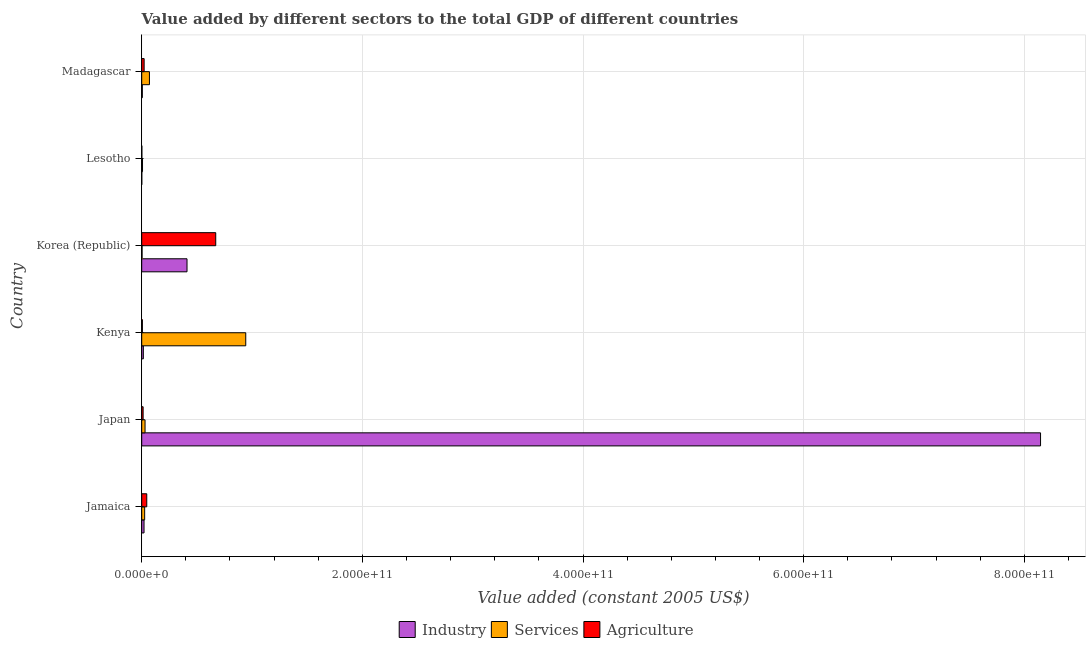How many groups of bars are there?
Give a very brief answer. 6. Are the number of bars on each tick of the Y-axis equal?
Give a very brief answer. Yes. What is the label of the 6th group of bars from the top?
Give a very brief answer. Jamaica. What is the value added by industrial sector in Kenya?
Your response must be concise. 1.46e+09. Across all countries, what is the maximum value added by services?
Your answer should be compact. 9.43e+1. Across all countries, what is the minimum value added by industrial sector?
Your answer should be very brief. 4.96e+07. In which country was the value added by services maximum?
Offer a terse response. Kenya. In which country was the value added by industrial sector minimum?
Give a very brief answer. Lesotho. What is the total value added by industrial sector in the graph?
Ensure brevity in your answer.  8.60e+11. What is the difference between the value added by services in Japan and that in Madagascar?
Give a very brief answer. -3.99e+09. What is the difference between the value added by industrial sector in Kenya and the value added by services in Jamaica?
Provide a short and direct response. -1.20e+09. What is the average value added by agricultural sector per country?
Your response must be concise. 1.26e+1. What is the difference between the value added by agricultural sector and value added by services in Korea (Republic)?
Keep it short and to the point. 6.68e+1. What is the ratio of the value added by industrial sector in Japan to that in Lesotho?
Your answer should be very brief. 1.64e+04. What is the difference between the highest and the second highest value added by industrial sector?
Ensure brevity in your answer.  7.74e+11. What is the difference between the highest and the lowest value added by agricultural sector?
Offer a terse response. 6.70e+1. Is the sum of the value added by agricultural sector in Kenya and Korea (Republic) greater than the maximum value added by services across all countries?
Give a very brief answer. No. What does the 1st bar from the top in Madagascar represents?
Keep it short and to the point. Agriculture. What does the 3rd bar from the bottom in Korea (Republic) represents?
Provide a short and direct response. Agriculture. How many bars are there?
Ensure brevity in your answer.  18. Are all the bars in the graph horizontal?
Provide a short and direct response. Yes. What is the difference between two consecutive major ticks on the X-axis?
Your answer should be compact. 2.00e+11. Where does the legend appear in the graph?
Give a very brief answer. Bottom center. How many legend labels are there?
Ensure brevity in your answer.  3. What is the title of the graph?
Keep it short and to the point. Value added by different sectors to the total GDP of different countries. What is the label or title of the X-axis?
Make the answer very short. Value added (constant 2005 US$). What is the Value added (constant 2005 US$) in Industry in Jamaica?
Keep it short and to the point. 2.10e+09. What is the Value added (constant 2005 US$) in Services in Jamaica?
Provide a short and direct response. 2.67e+09. What is the Value added (constant 2005 US$) of Agriculture in Jamaica?
Your answer should be very brief. 4.58e+09. What is the Value added (constant 2005 US$) in Industry in Japan?
Keep it short and to the point. 8.15e+11. What is the Value added (constant 2005 US$) in Services in Japan?
Your response must be concise. 3.01e+09. What is the Value added (constant 2005 US$) of Agriculture in Japan?
Make the answer very short. 1.27e+09. What is the Value added (constant 2005 US$) of Industry in Kenya?
Your answer should be compact. 1.46e+09. What is the Value added (constant 2005 US$) of Services in Kenya?
Your answer should be compact. 9.43e+1. What is the Value added (constant 2005 US$) of Agriculture in Kenya?
Your answer should be compact. 6.11e+08. What is the Value added (constant 2005 US$) of Industry in Korea (Republic)?
Your answer should be very brief. 4.11e+1. What is the Value added (constant 2005 US$) of Services in Korea (Republic)?
Offer a very short reply. 3.05e+08. What is the Value added (constant 2005 US$) in Agriculture in Korea (Republic)?
Your answer should be compact. 6.71e+1. What is the Value added (constant 2005 US$) of Industry in Lesotho?
Make the answer very short. 4.96e+07. What is the Value added (constant 2005 US$) in Services in Lesotho?
Provide a short and direct response. 7.20e+08. What is the Value added (constant 2005 US$) in Agriculture in Lesotho?
Provide a short and direct response. 1.21e+08. What is the Value added (constant 2005 US$) in Industry in Madagascar?
Offer a very short reply. 5.53e+08. What is the Value added (constant 2005 US$) in Services in Madagascar?
Provide a succinct answer. 7.00e+09. What is the Value added (constant 2005 US$) of Agriculture in Madagascar?
Your answer should be compact. 2.19e+09. Across all countries, what is the maximum Value added (constant 2005 US$) of Industry?
Offer a terse response. 8.15e+11. Across all countries, what is the maximum Value added (constant 2005 US$) of Services?
Give a very brief answer. 9.43e+1. Across all countries, what is the maximum Value added (constant 2005 US$) in Agriculture?
Your answer should be very brief. 6.71e+1. Across all countries, what is the minimum Value added (constant 2005 US$) of Industry?
Keep it short and to the point. 4.96e+07. Across all countries, what is the minimum Value added (constant 2005 US$) in Services?
Offer a terse response. 3.05e+08. Across all countries, what is the minimum Value added (constant 2005 US$) of Agriculture?
Your answer should be very brief. 1.21e+08. What is the total Value added (constant 2005 US$) in Industry in the graph?
Provide a succinct answer. 8.60e+11. What is the total Value added (constant 2005 US$) of Services in the graph?
Your response must be concise. 1.08e+11. What is the total Value added (constant 2005 US$) of Agriculture in the graph?
Make the answer very short. 7.59e+1. What is the difference between the Value added (constant 2005 US$) in Industry in Jamaica and that in Japan?
Give a very brief answer. -8.13e+11. What is the difference between the Value added (constant 2005 US$) in Services in Jamaica and that in Japan?
Make the answer very short. -3.45e+08. What is the difference between the Value added (constant 2005 US$) in Agriculture in Jamaica and that in Japan?
Provide a short and direct response. 3.31e+09. What is the difference between the Value added (constant 2005 US$) of Industry in Jamaica and that in Kenya?
Provide a succinct answer. 6.32e+08. What is the difference between the Value added (constant 2005 US$) in Services in Jamaica and that in Kenya?
Offer a terse response. -9.16e+1. What is the difference between the Value added (constant 2005 US$) of Agriculture in Jamaica and that in Kenya?
Give a very brief answer. 3.97e+09. What is the difference between the Value added (constant 2005 US$) of Industry in Jamaica and that in Korea (Republic)?
Offer a very short reply. -3.90e+1. What is the difference between the Value added (constant 2005 US$) in Services in Jamaica and that in Korea (Republic)?
Your response must be concise. 2.36e+09. What is the difference between the Value added (constant 2005 US$) of Agriculture in Jamaica and that in Korea (Republic)?
Give a very brief answer. -6.25e+1. What is the difference between the Value added (constant 2005 US$) of Industry in Jamaica and that in Lesotho?
Ensure brevity in your answer.  2.05e+09. What is the difference between the Value added (constant 2005 US$) of Services in Jamaica and that in Lesotho?
Provide a short and direct response. 1.95e+09. What is the difference between the Value added (constant 2005 US$) in Agriculture in Jamaica and that in Lesotho?
Your answer should be very brief. 4.46e+09. What is the difference between the Value added (constant 2005 US$) of Industry in Jamaica and that in Madagascar?
Your answer should be very brief. 1.54e+09. What is the difference between the Value added (constant 2005 US$) of Services in Jamaica and that in Madagascar?
Your response must be concise. -4.33e+09. What is the difference between the Value added (constant 2005 US$) in Agriculture in Jamaica and that in Madagascar?
Keep it short and to the point. 2.39e+09. What is the difference between the Value added (constant 2005 US$) in Industry in Japan and that in Kenya?
Provide a short and direct response. 8.13e+11. What is the difference between the Value added (constant 2005 US$) in Services in Japan and that in Kenya?
Keep it short and to the point. -9.13e+1. What is the difference between the Value added (constant 2005 US$) of Agriculture in Japan and that in Kenya?
Make the answer very short. 6.59e+08. What is the difference between the Value added (constant 2005 US$) in Industry in Japan and that in Korea (Republic)?
Your answer should be very brief. 7.74e+11. What is the difference between the Value added (constant 2005 US$) in Services in Japan and that in Korea (Republic)?
Provide a succinct answer. 2.71e+09. What is the difference between the Value added (constant 2005 US$) of Agriculture in Japan and that in Korea (Republic)?
Make the answer very short. -6.58e+1. What is the difference between the Value added (constant 2005 US$) in Industry in Japan and that in Lesotho?
Keep it short and to the point. 8.15e+11. What is the difference between the Value added (constant 2005 US$) in Services in Japan and that in Lesotho?
Your answer should be very brief. 2.29e+09. What is the difference between the Value added (constant 2005 US$) of Agriculture in Japan and that in Lesotho?
Provide a short and direct response. 1.15e+09. What is the difference between the Value added (constant 2005 US$) in Industry in Japan and that in Madagascar?
Keep it short and to the point. 8.14e+11. What is the difference between the Value added (constant 2005 US$) in Services in Japan and that in Madagascar?
Keep it short and to the point. -3.99e+09. What is the difference between the Value added (constant 2005 US$) in Agriculture in Japan and that in Madagascar?
Provide a short and direct response. -9.18e+08. What is the difference between the Value added (constant 2005 US$) in Industry in Kenya and that in Korea (Republic)?
Give a very brief answer. -3.96e+1. What is the difference between the Value added (constant 2005 US$) in Services in Kenya and that in Korea (Republic)?
Your response must be concise. 9.40e+1. What is the difference between the Value added (constant 2005 US$) in Agriculture in Kenya and that in Korea (Republic)?
Offer a terse response. -6.65e+1. What is the difference between the Value added (constant 2005 US$) in Industry in Kenya and that in Lesotho?
Provide a succinct answer. 1.41e+09. What is the difference between the Value added (constant 2005 US$) in Services in Kenya and that in Lesotho?
Offer a terse response. 9.36e+1. What is the difference between the Value added (constant 2005 US$) in Agriculture in Kenya and that in Lesotho?
Offer a very short reply. 4.90e+08. What is the difference between the Value added (constant 2005 US$) in Industry in Kenya and that in Madagascar?
Make the answer very short. 9.12e+08. What is the difference between the Value added (constant 2005 US$) of Services in Kenya and that in Madagascar?
Your response must be concise. 8.73e+1. What is the difference between the Value added (constant 2005 US$) in Agriculture in Kenya and that in Madagascar?
Keep it short and to the point. -1.58e+09. What is the difference between the Value added (constant 2005 US$) of Industry in Korea (Republic) and that in Lesotho?
Give a very brief answer. 4.10e+1. What is the difference between the Value added (constant 2005 US$) in Services in Korea (Republic) and that in Lesotho?
Your answer should be compact. -4.15e+08. What is the difference between the Value added (constant 2005 US$) in Agriculture in Korea (Republic) and that in Lesotho?
Your answer should be compact. 6.70e+1. What is the difference between the Value added (constant 2005 US$) of Industry in Korea (Republic) and that in Madagascar?
Provide a short and direct response. 4.05e+1. What is the difference between the Value added (constant 2005 US$) in Services in Korea (Republic) and that in Madagascar?
Make the answer very short. -6.69e+09. What is the difference between the Value added (constant 2005 US$) in Agriculture in Korea (Republic) and that in Madagascar?
Offer a very short reply. 6.49e+1. What is the difference between the Value added (constant 2005 US$) in Industry in Lesotho and that in Madagascar?
Give a very brief answer. -5.03e+08. What is the difference between the Value added (constant 2005 US$) of Services in Lesotho and that in Madagascar?
Provide a succinct answer. -6.28e+09. What is the difference between the Value added (constant 2005 US$) of Agriculture in Lesotho and that in Madagascar?
Your answer should be compact. -2.07e+09. What is the difference between the Value added (constant 2005 US$) in Industry in Jamaica and the Value added (constant 2005 US$) in Services in Japan?
Your answer should be very brief. -9.15e+08. What is the difference between the Value added (constant 2005 US$) in Industry in Jamaica and the Value added (constant 2005 US$) in Agriculture in Japan?
Make the answer very short. 8.26e+08. What is the difference between the Value added (constant 2005 US$) in Services in Jamaica and the Value added (constant 2005 US$) in Agriculture in Japan?
Provide a short and direct response. 1.40e+09. What is the difference between the Value added (constant 2005 US$) in Industry in Jamaica and the Value added (constant 2005 US$) in Services in Kenya?
Your answer should be very brief. -9.22e+1. What is the difference between the Value added (constant 2005 US$) of Industry in Jamaica and the Value added (constant 2005 US$) of Agriculture in Kenya?
Provide a succinct answer. 1.49e+09. What is the difference between the Value added (constant 2005 US$) of Services in Jamaica and the Value added (constant 2005 US$) of Agriculture in Kenya?
Make the answer very short. 2.06e+09. What is the difference between the Value added (constant 2005 US$) in Industry in Jamaica and the Value added (constant 2005 US$) in Services in Korea (Republic)?
Your response must be concise. 1.79e+09. What is the difference between the Value added (constant 2005 US$) of Industry in Jamaica and the Value added (constant 2005 US$) of Agriculture in Korea (Republic)?
Keep it short and to the point. -6.50e+1. What is the difference between the Value added (constant 2005 US$) in Services in Jamaica and the Value added (constant 2005 US$) in Agriculture in Korea (Republic)?
Ensure brevity in your answer.  -6.44e+1. What is the difference between the Value added (constant 2005 US$) of Industry in Jamaica and the Value added (constant 2005 US$) of Services in Lesotho?
Your answer should be very brief. 1.38e+09. What is the difference between the Value added (constant 2005 US$) of Industry in Jamaica and the Value added (constant 2005 US$) of Agriculture in Lesotho?
Give a very brief answer. 1.98e+09. What is the difference between the Value added (constant 2005 US$) in Services in Jamaica and the Value added (constant 2005 US$) in Agriculture in Lesotho?
Keep it short and to the point. 2.55e+09. What is the difference between the Value added (constant 2005 US$) of Industry in Jamaica and the Value added (constant 2005 US$) of Services in Madagascar?
Your answer should be compact. -4.90e+09. What is the difference between the Value added (constant 2005 US$) of Industry in Jamaica and the Value added (constant 2005 US$) of Agriculture in Madagascar?
Ensure brevity in your answer.  -9.23e+07. What is the difference between the Value added (constant 2005 US$) of Services in Jamaica and the Value added (constant 2005 US$) of Agriculture in Madagascar?
Give a very brief answer. 4.78e+08. What is the difference between the Value added (constant 2005 US$) in Industry in Japan and the Value added (constant 2005 US$) in Services in Kenya?
Give a very brief answer. 7.20e+11. What is the difference between the Value added (constant 2005 US$) of Industry in Japan and the Value added (constant 2005 US$) of Agriculture in Kenya?
Your answer should be very brief. 8.14e+11. What is the difference between the Value added (constant 2005 US$) of Services in Japan and the Value added (constant 2005 US$) of Agriculture in Kenya?
Offer a very short reply. 2.40e+09. What is the difference between the Value added (constant 2005 US$) in Industry in Japan and the Value added (constant 2005 US$) in Services in Korea (Republic)?
Keep it short and to the point. 8.14e+11. What is the difference between the Value added (constant 2005 US$) of Industry in Japan and the Value added (constant 2005 US$) of Agriculture in Korea (Republic)?
Your answer should be compact. 7.48e+11. What is the difference between the Value added (constant 2005 US$) of Services in Japan and the Value added (constant 2005 US$) of Agriculture in Korea (Republic)?
Provide a succinct answer. -6.41e+1. What is the difference between the Value added (constant 2005 US$) of Industry in Japan and the Value added (constant 2005 US$) of Services in Lesotho?
Ensure brevity in your answer.  8.14e+11. What is the difference between the Value added (constant 2005 US$) in Industry in Japan and the Value added (constant 2005 US$) in Agriculture in Lesotho?
Your answer should be very brief. 8.15e+11. What is the difference between the Value added (constant 2005 US$) in Services in Japan and the Value added (constant 2005 US$) in Agriculture in Lesotho?
Your answer should be compact. 2.89e+09. What is the difference between the Value added (constant 2005 US$) in Industry in Japan and the Value added (constant 2005 US$) in Services in Madagascar?
Your response must be concise. 8.08e+11. What is the difference between the Value added (constant 2005 US$) in Industry in Japan and the Value added (constant 2005 US$) in Agriculture in Madagascar?
Ensure brevity in your answer.  8.13e+11. What is the difference between the Value added (constant 2005 US$) in Services in Japan and the Value added (constant 2005 US$) in Agriculture in Madagascar?
Offer a terse response. 8.22e+08. What is the difference between the Value added (constant 2005 US$) of Industry in Kenya and the Value added (constant 2005 US$) of Services in Korea (Republic)?
Provide a short and direct response. 1.16e+09. What is the difference between the Value added (constant 2005 US$) of Industry in Kenya and the Value added (constant 2005 US$) of Agriculture in Korea (Republic)?
Your response must be concise. -6.56e+1. What is the difference between the Value added (constant 2005 US$) in Services in Kenya and the Value added (constant 2005 US$) in Agriculture in Korea (Republic)?
Keep it short and to the point. 2.72e+1. What is the difference between the Value added (constant 2005 US$) in Industry in Kenya and the Value added (constant 2005 US$) in Services in Lesotho?
Ensure brevity in your answer.  7.44e+08. What is the difference between the Value added (constant 2005 US$) in Industry in Kenya and the Value added (constant 2005 US$) in Agriculture in Lesotho?
Ensure brevity in your answer.  1.34e+09. What is the difference between the Value added (constant 2005 US$) of Services in Kenya and the Value added (constant 2005 US$) of Agriculture in Lesotho?
Your answer should be compact. 9.42e+1. What is the difference between the Value added (constant 2005 US$) of Industry in Kenya and the Value added (constant 2005 US$) of Services in Madagascar?
Ensure brevity in your answer.  -5.53e+09. What is the difference between the Value added (constant 2005 US$) in Industry in Kenya and the Value added (constant 2005 US$) in Agriculture in Madagascar?
Ensure brevity in your answer.  -7.24e+08. What is the difference between the Value added (constant 2005 US$) of Services in Kenya and the Value added (constant 2005 US$) of Agriculture in Madagascar?
Give a very brief answer. 9.21e+1. What is the difference between the Value added (constant 2005 US$) of Industry in Korea (Republic) and the Value added (constant 2005 US$) of Services in Lesotho?
Keep it short and to the point. 4.03e+1. What is the difference between the Value added (constant 2005 US$) of Industry in Korea (Republic) and the Value added (constant 2005 US$) of Agriculture in Lesotho?
Your answer should be compact. 4.09e+1. What is the difference between the Value added (constant 2005 US$) in Services in Korea (Republic) and the Value added (constant 2005 US$) in Agriculture in Lesotho?
Your answer should be compact. 1.84e+08. What is the difference between the Value added (constant 2005 US$) in Industry in Korea (Republic) and the Value added (constant 2005 US$) in Services in Madagascar?
Provide a short and direct response. 3.41e+1. What is the difference between the Value added (constant 2005 US$) in Industry in Korea (Republic) and the Value added (constant 2005 US$) in Agriculture in Madagascar?
Give a very brief answer. 3.89e+1. What is the difference between the Value added (constant 2005 US$) of Services in Korea (Republic) and the Value added (constant 2005 US$) of Agriculture in Madagascar?
Offer a very short reply. -1.88e+09. What is the difference between the Value added (constant 2005 US$) of Industry in Lesotho and the Value added (constant 2005 US$) of Services in Madagascar?
Provide a succinct answer. -6.95e+09. What is the difference between the Value added (constant 2005 US$) in Industry in Lesotho and the Value added (constant 2005 US$) in Agriculture in Madagascar?
Your response must be concise. -2.14e+09. What is the difference between the Value added (constant 2005 US$) of Services in Lesotho and the Value added (constant 2005 US$) of Agriculture in Madagascar?
Provide a succinct answer. -1.47e+09. What is the average Value added (constant 2005 US$) in Industry per country?
Your answer should be compact. 1.43e+11. What is the average Value added (constant 2005 US$) of Services per country?
Provide a short and direct response. 1.80e+1. What is the average Value added (constant 2005 US$) in Agriculture per country?
Give a very brief answer. 1.26e+1. What is the difference between the Value added (constant 2005 US$) of Industry and Value added (constant 2005 US$) of Services in Jamaica?
Keep it short and to the point. -5.70e+08. What is the difference between the Value added (constant 2005 US$) of Industry and Value added (constant 2005 US$) of Agriculture in Jamaica?
Offer a very short reply. -2.48e+09. What is the difference between the Value added (constant 2005 US$) of Services and Value added (constant 2005 US$) of Agriculture in Jamaica?
Give a very brief answer. -1.91e+09. What is the difference between the Value added (constant 2005 US$) of Industry and Value added (constant 2005 US$) of Services in Japan?
Provide a succinct answer. 8.12e+11. What is the difference between the Value added (constant 2005 US$) in Industry and Value added (constant 2005 US$) in Agriculture in Japan?
Provide a succinct answer. 8.13e+11. What is the difference between the Value added (constant 2005 US$) of Services and Value added (constant 2005 US$) of Agriculture in Japan?
Offer a very short reply. 1.74e+09. What is the difference between the Value added (constant 2005 US$) in Industry and Value added (constant 2005 US$) in Services in Kenya?
Provide a succinct answer. -9.28e+1. What is the difference between the Value added (constant 2005 US$) in Industry and Value added (constant 2005 US$) in Agriculture in Kenya?
Offer a terse response. 8.53e+08. What is the difference between the Value added (constant 2005 US$) of Services and Value added (constant 2005 US$) of Agriculture in Kenya?
Provide a short and direct response. 9.37e+1. What is the difference between the Value added (constant 2005 US$) of Industry and Value added (constant 2005 US$) of Services in Korea (Republic)?
Ensure brevity in your answer.  4.08e+1. What is the difference between the Value added (constant 2005 US$) of Industry and Value added (constant 2005 US$) of Agriculture in Korea (Republic)?
Your response must be concise. -2.60e+1. What is the difference between the Value added (constant 2005 US$) in Services and Value added (constant 2005 US$) in Agriculture in Korea (Republic)?
Provide a short and direct response. -6.68e+1. What is the difference between the Value added (constant 2005 US$) in Industry and Value added (constant 2005 US$) in Services in Lesotho?
Your answer should be very brief. -6.70e+08. What is the difference between the Value added (constant 2005 US$) in Industry and Value added (constant 2005 US$) in Agriculture in Lesotho?
Offer a terse response. -7.12e+07. What is the difference between the Value added (constant 2005 US$) in Services and Value added (constant 2005 US$) in Agriculture in Lesotho?
Provide a succinct answer. 5.99e+08. What is the difference between the Value added (constant 2005 US$) in Industry and Value added (constant 2005 US$) in Services in Madagascar?
Make the answer very short. -6.44e+09. What is the difference between the Value added (constant 2005 US$) in Industry and Value added (constant 2005 US$) in Agriculture in Madagascar?
Offer a very short reply. -1.64e+09. What is the difference between the Value added (constant 2005 US$) of Services and Value added (constant 2005 US$) of Agriculture in Madagascar?
Keep it short and to the point. 4.81e+09. What is the ratio of the Value added (constant 2005 US$) of Industry in Jamaica to that in Japan?
Ensure brevity in your answer.  0. What is the ratio of the Value added (constant 2005 US$) in Services in Jamaica to that in Japan?
Make the answer very short. 0.89. What is the ratio of the Value added (constant 2005 US$) in Agriculture in Jamaica to that in Japan?
Give a very brief answer. 3.6. What is the ratio of the Value added (constant 2005 US$) of Industry in Jamaica to that in Kenya?
Your response must be concise. 1.43. What is the ratio of the Value added (constant 2005 US$) in Services in Jamaica to that in Kenya?
Your answer should be compact. 0.03. What is the ratio of the Value added (constant 2005 US$) of Agriculture in Jamaica to that in Kenya?
Ensure brevity in your answer.  7.49. What is the ratio of the Value added (constant 2005 US$) in Industry in Jamaica to that in Korea (Republic)?
Keep it short and to the point. 0.05. What is the ratio of the Value added (constant 2005 US$) of Services in Jamaica to that in Korea (Republic)?
Provide a succinct answer. 8.75. What is the ratio of the Value added (constant 2005 US$) in Agriculture in Jamaica to that in Korea (Republic)?
Give a very brief answer. 0.07. What is the ratio of the Value added (constant 2005 US$) of Industry in Jamaica to that in Lesotho?
Your response must be concise. 42.25. What is the ratio of the Value added (constant 2005 US$) of Services in Jamaica to that in Lesotho?
Provide a short and direct response. 3.7. What is the ratio of the Value added (constant 2005 US$) of Agriculture in Jamaica to that in Lesotho?
Your answer should be very brief. 37.89. What is the ratio of the Value added (constant 2005 US$) in Industry in Jamaica to that in Madagascar?
Your response must be concise. 3.79. What is the ratio of the Value added (constant 2005 US$) in Services in Jamaica to that in Madagascar?
Your answer should be compact. 0.38. What is the ratio of the Value added (constant 2005 US$) in Agriculture in Jamaica to that in Madagascar?
Keep it short and to the point. 2.09. What is the ratio of the Value added (constant 2005 US$) in Industry in Japan to that in Kenya?
Your response must be concise. 556.49. What is the ratio of the Value added (constant 2005 US$) in Services in Japan to that in Kenya?
Ensure brevity in your answer.  0.03. What is the ratio of the Value added (constant 2005 US$) of Agriculture in Japan to that in Kenya?
Your answer should be compact. 2.08. What is the ratio of the Value added (constant 2005 US$) of Industry in Japan to that in Korea (Republic)?
Offer a very short reply. 19.84. What is the ratio of the Value added (constant 2005 US$) in Services in Japan to that in Korea (Republic)?
Give a very brief answer. 9.88. What is the ratio of the Value added (constant 2005 US$) in Agriculture in Japan to that in Korea (Republic)?
Ensure brevity in your answer.  0.02. What is the ratio of the Value added (constant 2005 US$) in Industry in Japan to that in Lesotho?
Your answer should be very brief. 1.64e+04. What is the ratio of the Value added (constant 2005 US$) in Services in Japan to that in Lesotho?
Offer a very short reply. 4.18. What is the ratio of the Value added (constant 2005 US$) in Agriculture in Japan to that in Lesotho?
Your response must be concise. 10.51. What is the ratio of the Value added (constant 2005 US$) of Industry in Japan to that in Madagascar?
Keep it short and to the point. 1474.61. What is the ratio of the Value added (constant 2005 US$) in Services in Japan to that in Madagascar?
Your response must be concise. 0.43. What is the ratio of the Value added (constant 2005 US$) in Agriculture in Japan to that in Madagascar?
Your response must be concise. 0.58. What is the ratio of the Value added (constant 2005 US$) in Industry in Kenya to that in Korea (Republic)?
Provide a short and direct response. 0.04. What is the ratio of the Value added (constant 2005 US$) in Services in Kenya to that in Korea (Republic)?
Make the answer very short. 309.5. What is the ratio of the Value added (constant 2005 US$) of Agriculture in Kenya to that in Korea (Republic)?
Provide a short and direct response. 0.01. What is the ratio of the Value added (constant 2005 US$) of Industry in Kenya to that in Lesotho?
Your answer should be compact. 29.52. What is the ratio of the Value added (constant 2005 US$) in Services in Kenya to that in Lesotho?
Provide a short and direct response. 131.03. What is the ratio of the Value added (constant 2005 US$) of Agriculture in Kenya to that in Lesotho?
Ensure brevity in your answer.  5.06. What is the ratio of the Value added (constant 2005 US$) in Industry in Kenya to that in Madagascar?
Give a very brief answer. 2.65. What is the ratio of the Value added (constant 2005 US$) of Services in Kenya to that in Madagascar?
Offer a terse response. 13.48. What is the ratio of the Value added (constant 2005 US$) in Agriculture in Kenya to that in Madagascar?
Offer a very short reply. 0.28. What is the ratio of the Value added (constant 2005 US$) of Industry in Korea (Republic) to that in Lesotho?
Provide a succinct answer. 827.79. What is the ratio of the Value added (constant 2005 US$) in Services in Korea (Republic) to that in Lesotho?
Make the answer very short. 0.42. What is the ratio of the Value added (constant 2005 US$) of Agriculture in Korea (Republic) to that in Lesotho?
Make the answer very short. 555.24. What is the ratio of the Value added (constant 2005 US$) of Industry in Korea (Republic) to that in Madagascar?
Ensure brevity in your answer.  74.32. What is the ratio of the Value added (constant 2005 US$) in Services in Korea (Republic) to that in Madagascar?
Give a very brief answer. 0.04. What is the ratio of the Value added (constant 2005 US$) in Agriculture in Korea (Republic) to that in Madagascar?
Provide a short and direct response. 30.66. What is the ratio of the Value added (constant 2005 US$) in Industry in Lesotho to that in Madagascar?
Ensure brevity in your answer.  0.09. What is the ratio of the Value added (constant 2005 US$) in Services in Lesotho to that in Madagascar?
Your answer should be very brief. 0.1. What is the ratio of the Value added (constant 2005 US$) in Agriculture in Lesotho to that in Madagascar?
Your response must be concise. 0.06. What is the difference between the highest and the second highest Value added (constant 2005 US$) in Industry?
Make the answer very short. 7.74e+11. What is the difference between the highest and the second highest Value added (constant 2005 US$) of Services?
Your answer should be very brief. 8.73e+1. What is the difference between the highest and the second highest Value added (constant 2005 US$) in Agriculture?
Ensure brevity in your answer.  6.25e+1. What is the difference between the highest and the lowest Value added (constant 2005 US$) of Industry?
Keep it short and to the point. 8.15e+11. What is the difference between the highest and the lowest Value added (constant 2005 US$) of Services?
Your response must be concise. 9.40e+1. What is the difference between the highest and the lowest Value added (constant 2005 US$) in Agriculture?
Keep it short and to the point. 6.70e+1. 